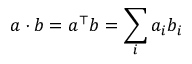Convert formula to latex. <formula><loc_0><loc_0><loc_500><loc_500>a \cdot b = a ^ { \top } b = \sum _ { i } a _ { i } b _ { i }</formula> 